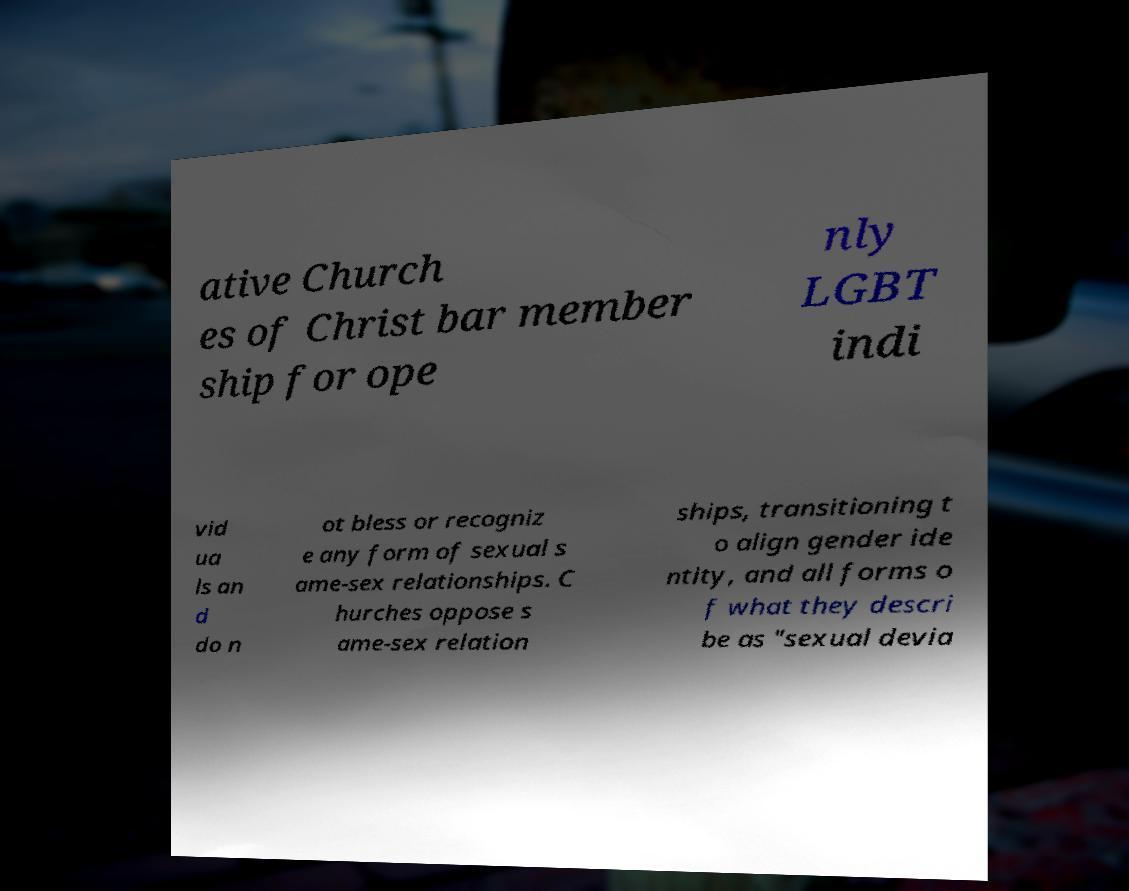For documentation purposes, I need the text within this image transcribed. Could you provide that? ative Church es of Christ bar member ship for ope nly LGBT indi vid ua ls an d do n ot bless or recogniz e any form of sexual s ame-sex relationships. C hurches oppose s ame-sex relation ships, transitioning t o align gender ide ntity, and all forms o f what they descri be as "sexual devia 